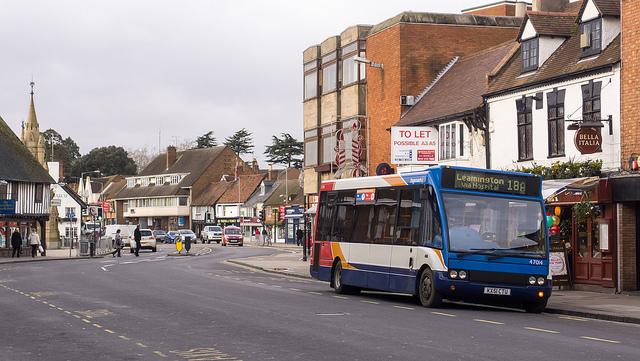Was this pic taken in the city?
Give a very brief answer. Yes. Is this a busy road?
Short answer required. No. What color is the bus?
Concise answer only. Blue. What kind of ride is history?
Give a very brief answer. Bus. What is number on the blue bus with gold numbers?
Answer briefly. 18. Are there people walking?
Quick response, please. Yes. Why are there brick rectangles coming out of the roofs?
Quick response, please. Windows. 